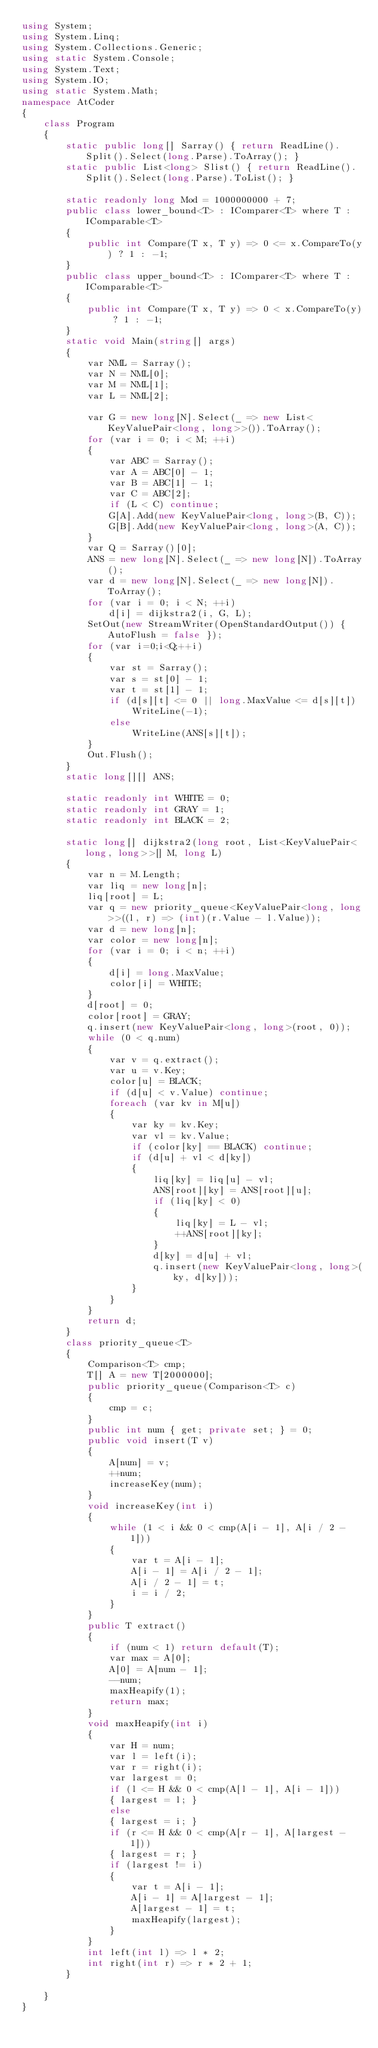Convert code to text. <code><loc_0><loc_0><loc_500><loc_500><_C#_>using System;
using System.Linq;
using System.Collections.Generic;
using static System.Console;
using System.Text;
using System.IO;
using static System.Math;
namespace AtCoder
{
    class Program
    {
        static public long[] Sarray() { return ReadLine().Split().Select(long.Parse).ToArray(); }
        static public List<long> Slist() { return ReadLine().Split().Select(long.Parse).ToList(); }

        static readonly long Mod = 1000000000 + 7;
        public class lower_bound<T> : IComparer<T> where T : IComparable<T>
        {
            public int Compare(T x, T y) => 0 <= x.CompareTo(y) ? 1 : -1;
        }
        public class upper_bound<T> : IComparer<T> where T : IComparable<T>
        {
            public int Compare(T x, T y) => 0 < x.CompareTo(y) ? 1 : -1;
        }
        static void Main(string[] args)
        {
            var NML = Sarray();
            var N = NML[0];
            var M = NML[1];
            var L = NML[2];

            var G = new long[N].Select(_ => new List<KeyValuePair<long, long>>()).ToArray();
            for (var i = 0; i < M; ++i)
            {
                var ABC = Sarray();
                var A = ABC[0] - 1;
                var B = ABC[1] - 1;
                var C = ABC[2];
                if (L < C) continue;
                G[A].Add(new KeyValuePair<long, long>(B, C));
                G[B].Add(new KeyValuePair<long, long>(A, C));
            }
            var Q = Sarray()[0];
            ANS = new long[N].Select(_ => new long[N]).ToArray();
            var d = new long[N].Select(_ => new long[N]).ToArray();
            for (var i = 0; i < N; ++i)
                d[i] = dijkstra2(i, G, L);
            SetOut(new StreamWriter(OpenStandardOutput()) { AutoFlush = false });
            for (var i=0;i<Q;++i)
            {
                var st = Sarray();
                var s = st[0] - 1;
                var t = st[1] - 1;
                if (d[s][t] <= 0 || long.MaxValue <= d[s][t]) 
                    WriteLine(-1);
                else
                    WriteLine(ANS[s][t]);
            }
            Out.Flush();
        }
        static long[][] ANS;

        static readonly int WHITE = 0;
        static readonly int GRAY = 1;
        static readonly int BLACK = 2;

        static long[] dijkstra2(long root, List<KeyValuePair<long, long>>[] M, long L)
        {
            var n = M.Length;
            var liq = new long[n];
            liq[root] = L;
            var q = new priority_queue<KeyValuePair<long, long>>((l, r) => (int)(r.Value - l.Value));
            var d = new long[n];
            var color = new long[n];
            for (var i = 0; i < n; ++i)
            {
                d[i] = long.MaxValue;
                color[i] = WHITE;
            }
            d[root] = 0;
            color[root] = GRAY;
            q.insert(new KeyValuePair<long, long>(root, 0));
            while (0 < q.num)
            {
                var v = q.extract();
                var u = v.Key;
                color[u] = BLACK;
                if (d[u] < v.Value) continue;
                foreach (var kv in M[u])
                {
                    var ky = kv.Key;
                    var vl = kv.Value;
                    if (color[ky] == BLACK) continue;
                    if (d[u] + vl < d[ky])
                    {
                        liq[ky] = liq[u] - vl;
                        ANS[root][ky] = ANS[root][u];
                        if (liq[ky] < 0)
                        {
                            liq[ky] = L - vl;
                            ++ANS[root][ky];
                        }
                        d[ky] = d[u] + vl;
                        q.insert(new KeyValuePair<long, long>(ky, d[ky]));
                    }
                }
            }
            return d;
        }
        class priority_queue<T>
        {
            Comparison<T> cmp;
            T[] A = new T[2000000];
            public priority_queue(Comparison<T> c)
            {
                cmp = c;
            }
            public int num { get; private set; } = 0;
            public void insert(T v)
            {
                A[num] = v;
                ++num;
                increaseKey(num);
            }
            void increaseKey(int i)
            {
                while (1 < i && 0 < cmp(A[i - 1], A[i / 2 - 1]))
                {
                    var t = A[i - 1];
                    A[i - 1] = A[i / 2 - 1];
                    A[i / 2 - 1] = t;
                    i = i / 2;
                }
            }
            public T extract()
            {
                if (num < 1) return default(T);
                var max = A[0];
                A[0] = A[num - 1];
                --num;
                maxHeapify(1);
                return max;
            }
            void maxHeapify(int i)
            {
                var H = num;
                var l = left(i);
                var r = right(i);
                var largest = 0;
                if (l <= H && 0 < cmp(A[l - 1], A[i - 1]))
                { largest = l; }
                else
                { largest = i; }
                if (r <= H && 0 < cmp(A[r - 1], A[largest - 1]))
                { largest = r; }
                if (largest != i)
                {
                    var t = A[i - 1];
                    A[i - 1] = A[largest - 1];
                    A[largest - 1] = t;
                    maxHeapify(largest);
                }
            }
            int left(int l) => l * 2;
            int right(int r) => r * 2 + 1;
        }

    }
}</code> 